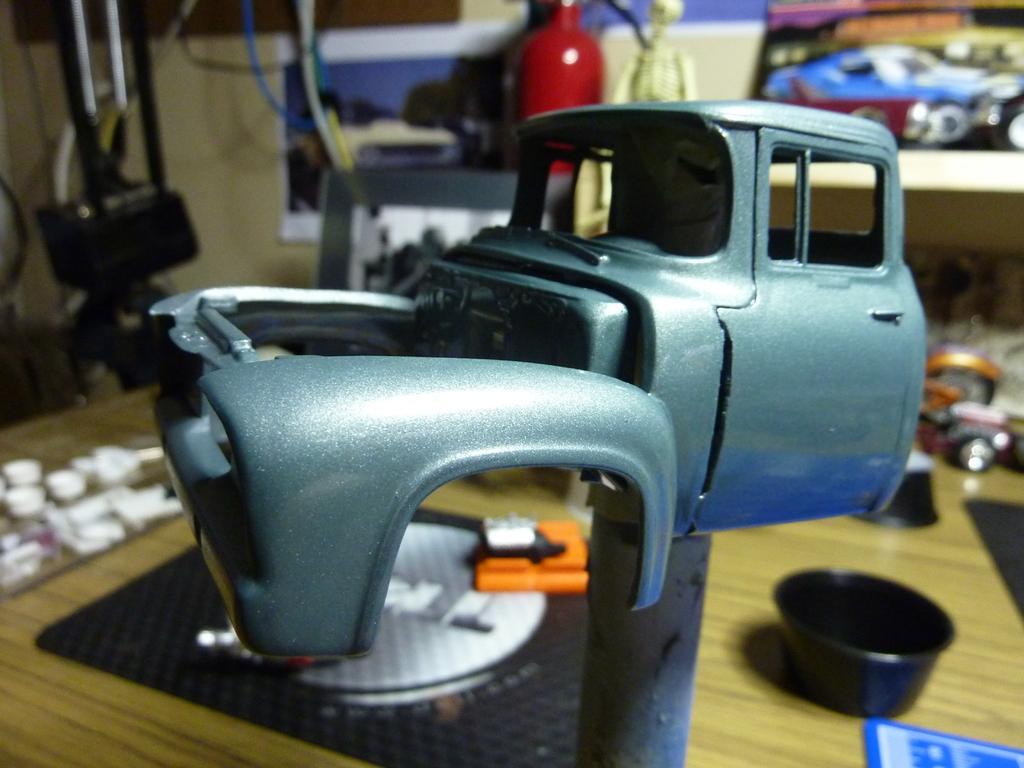In one or two sentences, can you explain what this image depicts? In this image we can see part of a toy vehicle on a stand. In the back we can see a wooden surface. On that there is a box and some other things. In the back there are wires, toys and some other things. And in the background it is looking blur. 